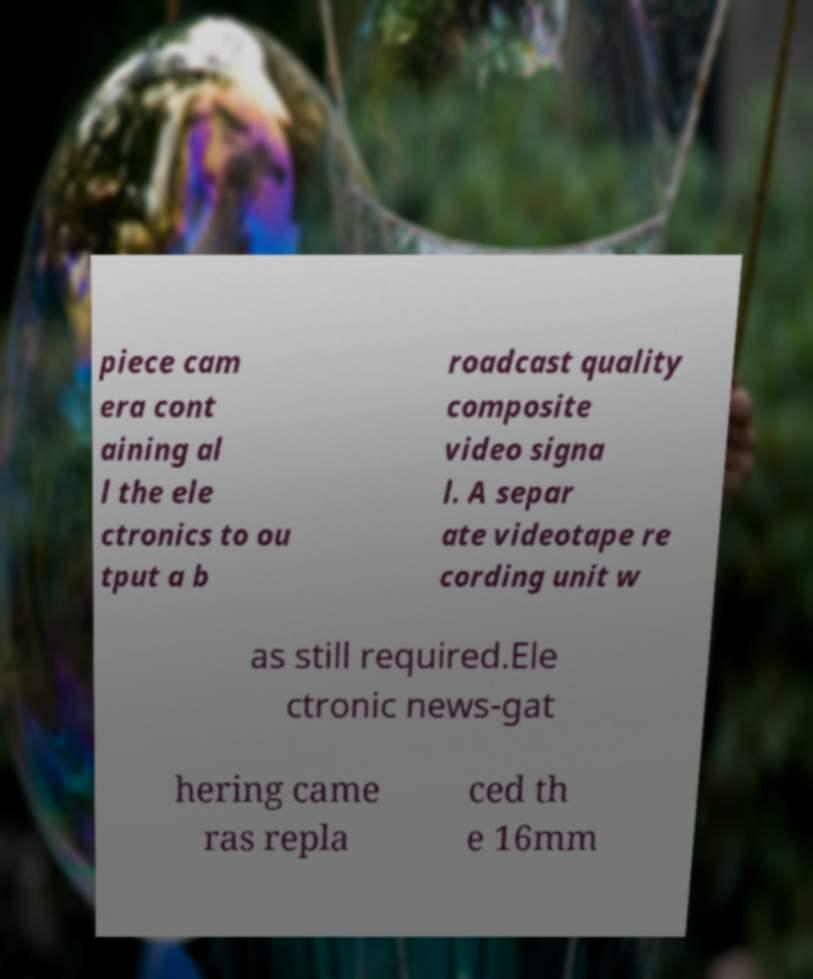Please identify and transcribe the text found in this image. piece cam era cont aining al l the ele ctronics to ou tput a b roadcast quality composite video signa l. A separ ate videotape re cording unit w as still required.Ele ctronic news-gat hering came ras repla ced th e 16mm 